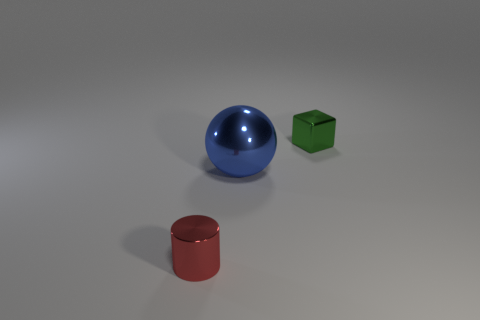Add 3 tiny blocks. How many objects exist? 6 Subtract all cylinders. How many objects are left? 2 Add 2 blue metal objects. How many blue metal objects are left? 3 Add 2 big things. How many big things exist? 3 Subtract 1 green blocks. How many objects are left? 2 Subtract all big rubber balls. Subtract all small metallic blocks. How many objects are left? 2 